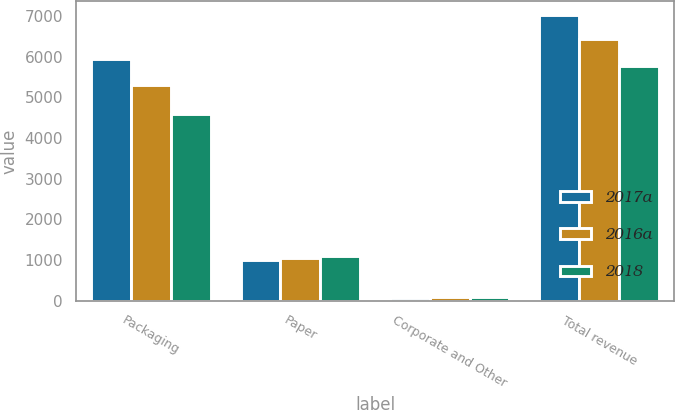Convert chart to OTSL. <chart><loc_0><loc_0><loc_500><loc_500><stacked_bar_chart><ecel><fcel>Packaging<fcel>Paper<fcel>Corporate and Other<fcel>Total revenue<nl><fcel>2017a<fcel>5938.5<fcel>1002<fcel>74.1<fcel>7014.6<nl><fcel>2016a<fcel>5312.3<fcel>1051.8<fcel>80.8<fcel>6444.9<nl><fcel>2018<fcel>4584.8<fcel>1093.9<fcel>100.3<fcel>5779<nl></chart> 